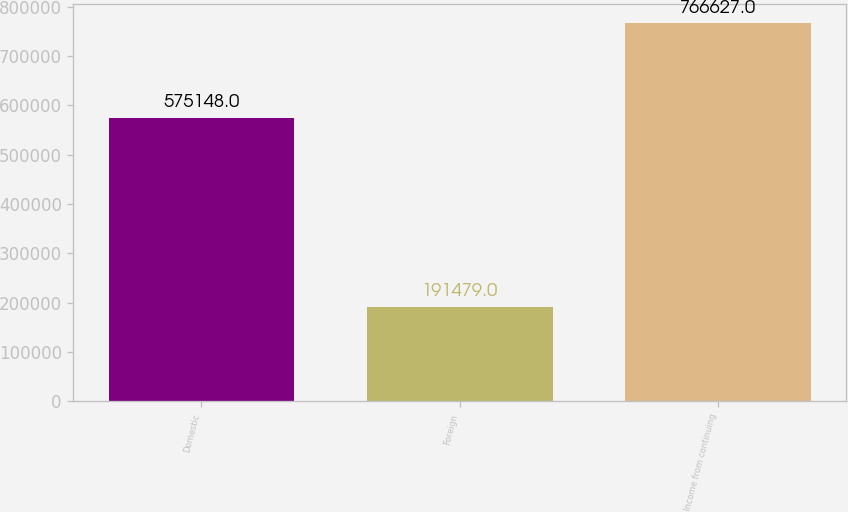Convert chart to OTSL. <chart><loc_0><loc_0><loc_500><loc_500><bar_chart><fcel>Domestic<fcel>Foreign<fcel>Income from continuing<nl><fcel>575148<fcel>191479<fcel>766627<nl></chart> 